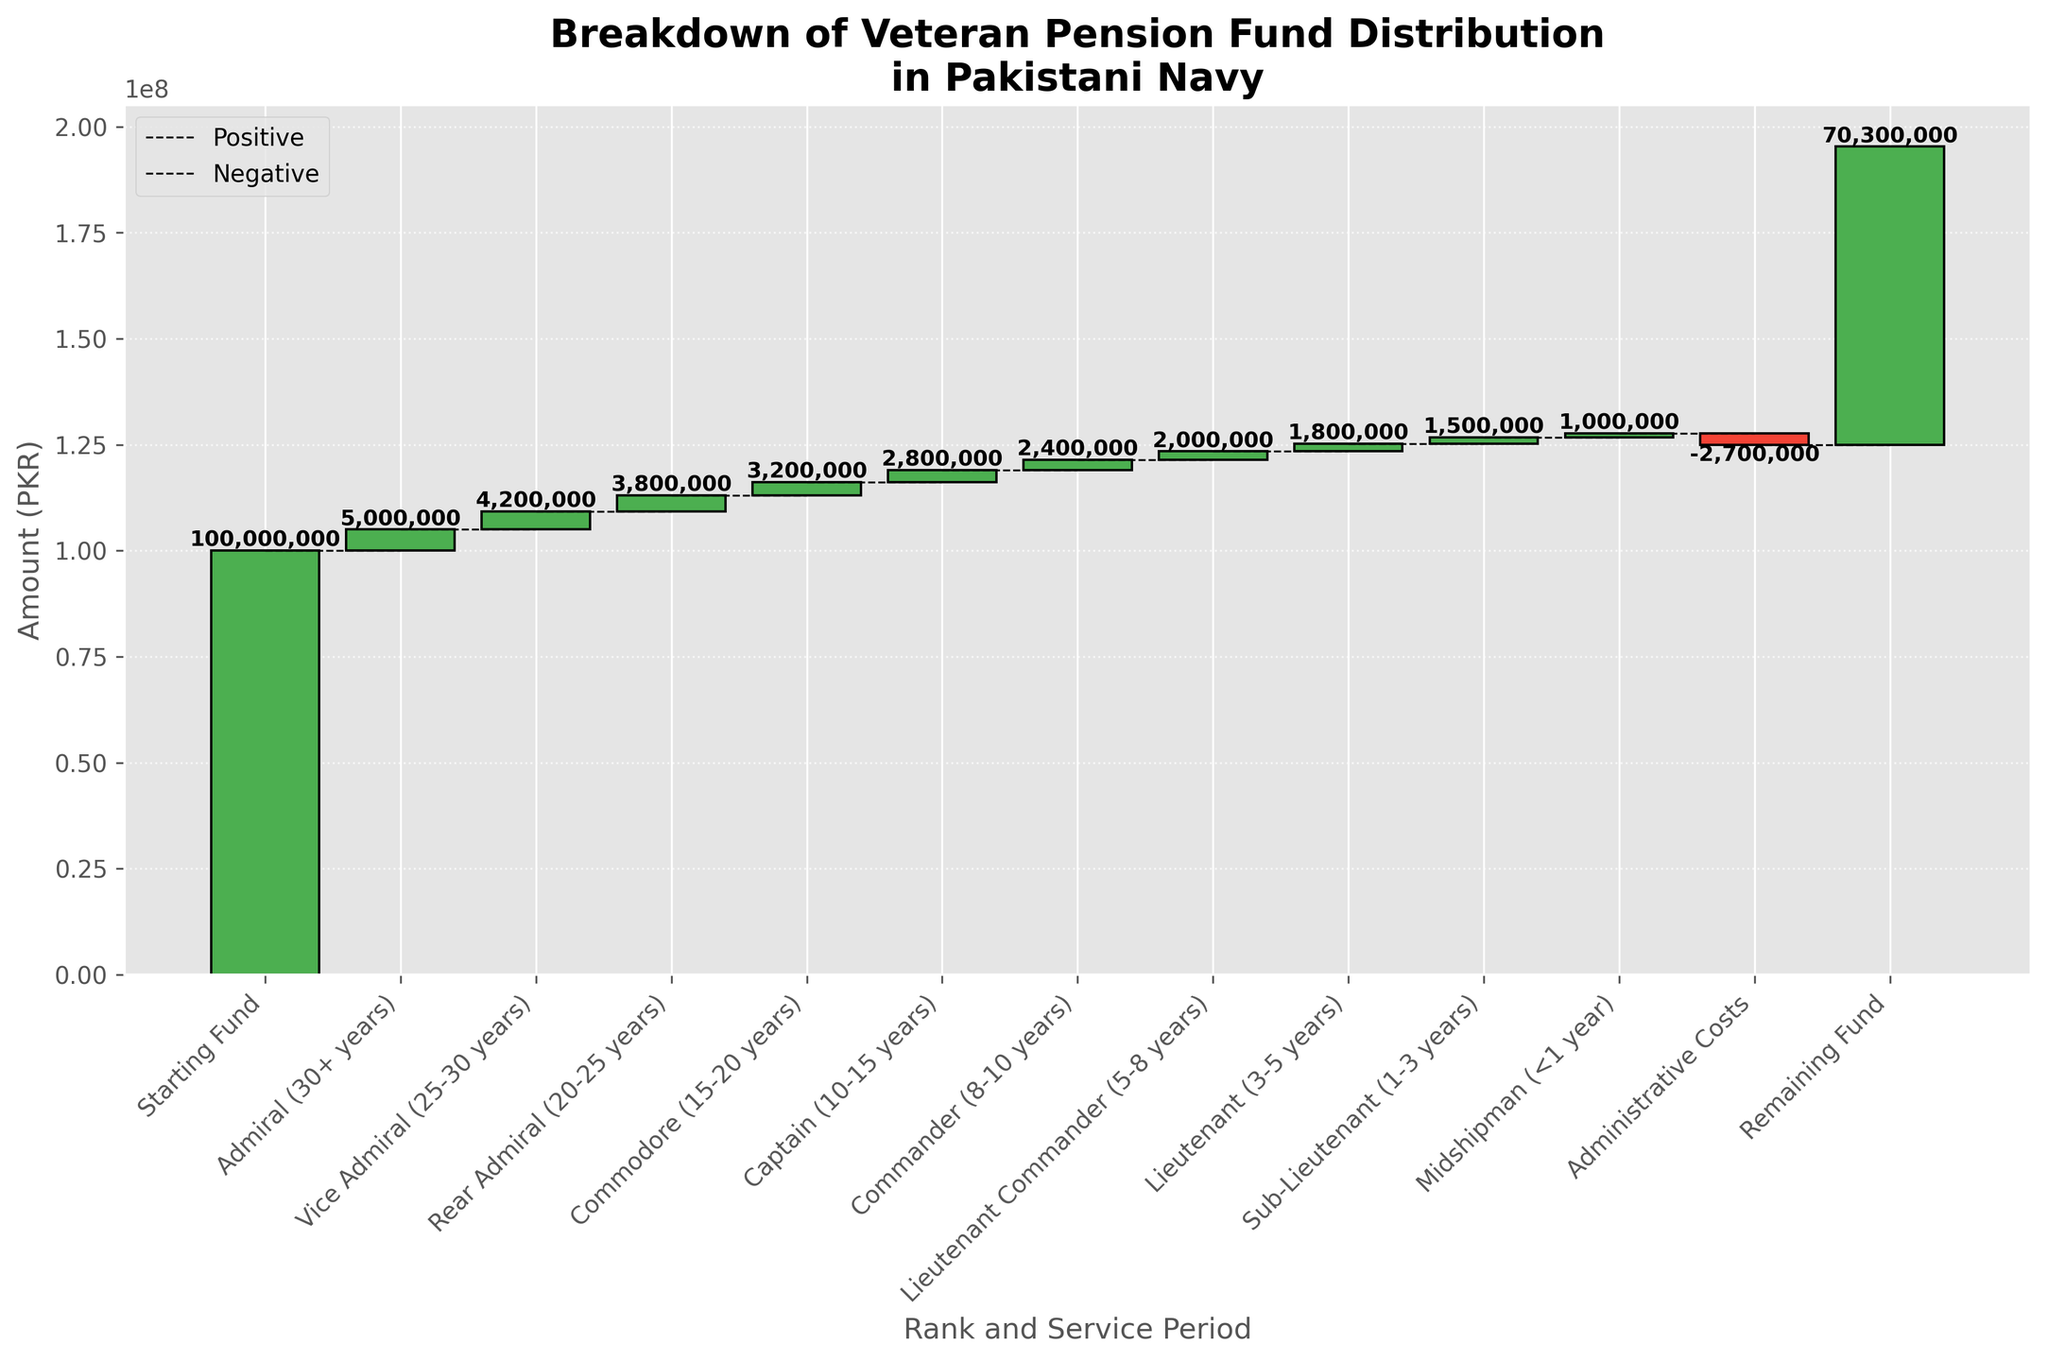What is the total starting fund amount? The total starting fund is the initial amount before any distribution among different ranks and service periods. According to the figure, the starting fund is labeled as "Starting Fund".
Answer: 100,000,000 PKR What are the axis labels in the figure? The x-axis is labeled as "Rank and Service Period", and the y-axis is labeled as "Amount (PKR)". These labels provide context for interpreting the categories and values within the chart.
Answer: "Rank and Service Period" and "Amount (PKR)" Which category had the smallest positive contribution to the pension fund? By observing the heights of the bars, the category "Midshipman (<1 year)" had the smallest positive contribution, as its bar is the shortest among the positive values.
Answer: Midshipman (<1 year) What is the cumulative amount after accounting for the Vice Admiral (25-30 years) contribution? Starting from 100,000,000 PKR, after accounting for the contributions of Admiral (30+ years) and Vice Admiral (25-30 years), the cumulative amount is 100,000,000 - 5,000,000 - 4,200,000.
Answer: 90,800,000 PKR What is the total amount contributed by all ranks in the 10 to 20 years service period? The contributions for Commodore (15-20 years) and Captain (10-15 years) need to be summed up, which are 3,200,000 PKR and 2,800,000 PKR, respectively.
Answer: 6,000,000 PKR How does the administrative cost affect the fund? The administrative cost is shown as a negative value, decreasing the remaining amount. The figure shows it as -2,700,000 PKR, reducing the amount from the cumulative fund by this value.
Answer: Decreases by 2,700,000 PKR Which rank and service period has the highest positive contribution after Admiral (30+ years)? Observing the bars and their respective categories, Vice Admiral (25-30 years) has the next highest positive contribution after Admiral (30+ years).
Answer: Vice Admiral (25-30 years) How much is the remaining fund at the end? According to the cumulative steps in the figure, the remaining fund is labeled explicitly and is a result of subtracting all contributions and costs from the starting fund. The remaining fund amount is shown as "Remaining Fund".
Answer: 70,300,000 PKR Which category has the highest cumulative contribution, excluding negative values? Admiral (30+ years) has the highest individual positive contribution at 5,000,000 PKR, making it the highest cumulative contribution counted individually and excluding other positive contributions.
Answer: Admiral (30+ years) What percentage of the starting fund remains after all distributions and administrative costs? The percentage can be calculated using the formula: (Remaining Fund / Starting Fund) * 100. The remaining fund is 70,300,000 PKR, and the starting fund is 100,000,000 PKR. Thus, the calculation is (70,300,000 / 100,000,000) * 100.
Answer: 70.3% 